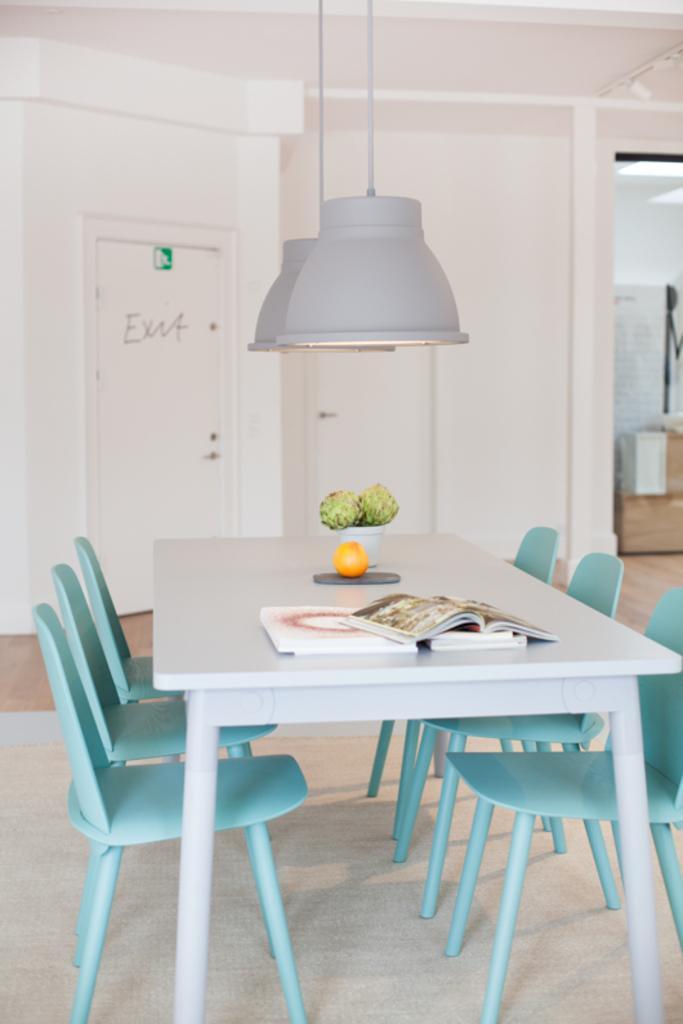Could you give a brief overview of what you see in this image? In this image we can see a dining table, and some chairs, there are books, fruit and a house plant on top of the table, there are two hanging lights, also we can see the walls, doors, boxes, there is a text on a door. 